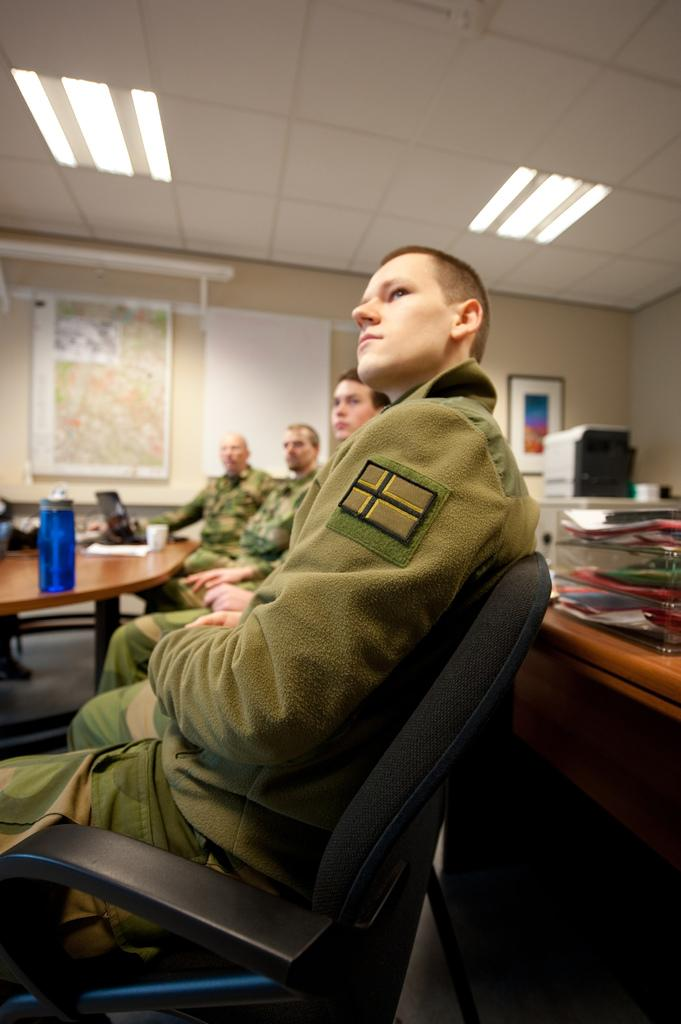How many people are in the image? There is a group of people in the image. What are the people doing in the image? The people are sitting in front of a table. What objects can be seen on the table? There is a bottle and a laptop on the table. What can be seen on the wall in the background? There are frames attached to the wall in the background. Can you find the receipt for the laptop purchase in the image? There is no receipt visible in the image. What impulse caused the people to gather around the table in the image? The image does not provide information about the reason or impulse for the people to gather around the table. 